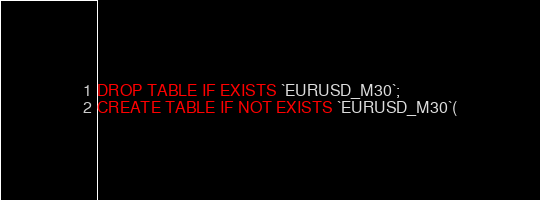Convert code to text. <code><loc_0><loc_0><loc_500><loc_500><_SQL_>DROP TABLE IF EXISTS `EURUSD_M30`;
CREATE TABLE IF NOT EXISTS `EURUSD_M30`(</code> 